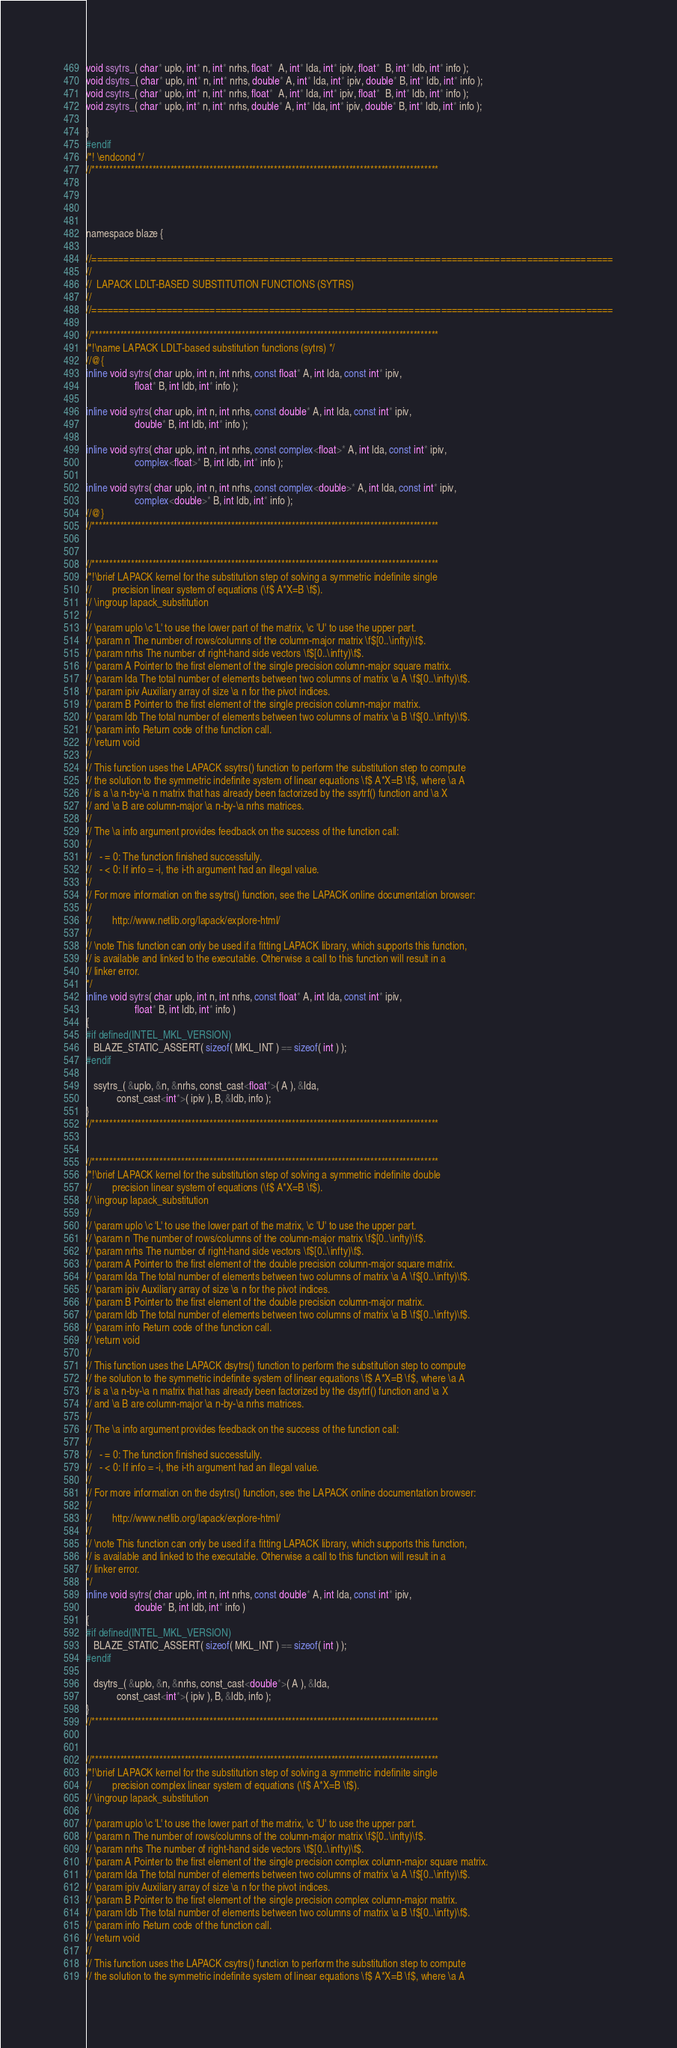Convert code to text. <code><loc_0><loc_0><loc_500><loc_500><_C_>
void ssytrs_( char* uplo, int* n, int* nrhs, float*  A, int* lda, int* ipiv, float*  B, int* ldb, int* info );
void dsytrs_( char* uplo, int* n, int* nrhs, double* A, int* lda, int* ipiv, double* B, int* ldb, int* info );
void csytrs_( char* uplo, int* n, int* nrhs, float*  A, int* lda, int* ipiv, float*  B, int* ldb, int* info );
void zsytrs_( char* uplo, int* n, int* nrhs, double* A, int* lda, int* ipiv, double* B, int* ldb, int* info );

}
#endif
/*! \endcond */
//*************************************************************************************************




namespace blaze {

//=================================================================================================
//
//  LAPACK LDLT-BASED SUBSTITUTION FUNCTIONS (SYTRS)
//
//=================================================================================================

//*************************************************************************************************
/*!\name LAPACK LDLT-based substitution functions (sytrs) */
//@{
inline void sytrs( char uplo, int n, int nrhs, const float* A, int lda, const int* ipiv,
                   float* B, int ldb, int* info );

inline void sytrs( char uplo, int n, int nrhs, const double* A, int lda, const int* ipiv,
                   double* B, int ldb, int* info );

inline void sytrs( char uplo, int n, int nrhs, const complex<float>* A, int lda, const int* ipiv,
                   complex<float>* B, int ldb, int* info );

inline void sytrs( char uplo, int n, int nrhs, const complex<double>* A, int lda, const int* ipiv,
                   complex<double>* B, int ldb, int* info );
//@}
//*************************************************************************************************


//*************************************************************************************************
/*!\brief LAPACK kernel for the substitution step of solving a symmetric indefinite single
//        precision linear system of equations (\f$ A*X=B \f$).
// \ingroup lapack_substitution
//
// \param uplo \c 'L' to use the lower part of the matrix, \c 'U' to use the upper part.
// \param n The number of rows/columns of the column-major matrix \f$[0..\infty)\f$.
// \param nrhs The number of right-hand side vectors \f$[0..\infty)\f$.
// \param A Pointer to the first element of the single precision column-major square matrix.
// \param lda The total number of elements between two columns of matrix \a A \f$[0..\infty)\f$.
// \param ipiv Auxiliary array of size \a n for the pivot indices.
// \param B Pointer to the first element of the single precision column-major matrix.
// \param ldb The total number of elements between two columns of matrix \a B \f$[0..\infty)\f$.
// \param info Return code of the function call.
// \return void
//
// This function uses the LAPACK ssytrs() function to perform the substitution step to compute
// the solution to the symmetric indefinite system of linear equations \f$ A*X=B \f$, where \a A
// is a \a n-by-\a n matrix that has already been factorized by the ssytrf() function and \a X
// and \a B are column-major \a n-by-\a nrhs matrices.
//
// The \a info argument provides feedback on the success of the function call:
//
//   - = 0: The function finished successfully.
//   - < 0: If info = -i, the i-th argument had an illegal value.
//
// For more information on the ssytrs() function, see the LAPACK online documentation browser:
//
//        http://www.netlib.org/lapack/explore-html/
//
// \note This function can only be used if a fitting LAPACK library, which supports this function,
// is available and linked to the executable. Otherwise a call to this function will result in a
// linker error.
*/
inline void sytrs( char uplo, int n, int nrhs, const float* A, int lda, const int* ipiv,
                   float* B, int ldb, int* info )
{
#if defined(INTEL_MKL_VERSION)
   BLAZE_STATIC_ASSERT( sizeof( MKL_INT ) == sizeof( int ) );
#endif

   ssytrs_( &uplo, &n, &nrhs, const_cast<float*>( A ), &lda,
            const_cast<int*>( ipiv ), B, &ldb, info );
}
//*************************************************************************************************


//*************************************************************************************************
/*!\brief LAPACK kernel for the substitution step of solving a symmetric indefinite double
//        precision linear system of equations (\f$ A*X=B \f$).
// \ingroup lapack_substitution
//
// \param uplo \c 'L' to use the lower part of the matrix, \c 'U' to use the upper part.
// \param n The number of rows/columns of the column-major matrix \f$[0..\infty)\f$.
// \param nrhs The number of right-hand side vectors \f$[0..\infty)\f$.
// \param A Pointer to the first element of the double precision column-major square matrix.
// \param lda The total number of elements between two columns of matrix \a A \f$[0..\infty)\f$.
// \param ipiv Auxiliary array of size \a n for the pivot indices.
// \param B Pointer to the first element of the double precision column-major matrix.
// \param ldb The total number of elements between two columns of matrix \a B \f$[0..\infty)\f$.
// \param info Return code of the function call.
// \return void
//
// This function uses the LAPACK dsytrs() function to perform the substitution step to compute
// the solution to the symmetric indefinite system of linear equations \f$ A*X=B \f$, where \a A
// is a \a n-by-\a n matrix that has already been factorized by the dsytrf() function and \a X
// and \a B are column-major \a n-by-\a nrhs matrices.
//
// The \a info argument provides feedback on the success of the function call:
//
//   - = 0: The function finished successfully.
//   - < 0: If info = -i, the i-th argument had an illegal value.
//
// For more information on the dsytrs() function, see the LAPACK online documentation browser:
//
//        http://www.netlib.org/lapack/explore-html/
//
// \note This function can only be used if a fitting LAPACK library, which supports this function,
// is available and linked to the executable. Otherwise a call to this function will result in a
// linker error.
*/
inline void sytrs( char uplo, int n, int nrhs, const double* A, int lda, const int* ipiv,
                   double* B, int ldb, int* info )
{
#if defined(INTEL_MKL_VERSION)
   BLAZE_STATIC_ASSERT( sizeof( MKL_INT ) == sizeof( int ) );
#endif

   dsytrs_( &uplo, &n, &nrhs, const_cast<double*>( A ), &lda,
            const_cast<int*>( ipiv ), B, &ldb, info );
}
//*************************************************************************************************


//*************************************************************************************************
/*!\brief LAPACK kernel for the substitution step of solving a symmetric indefinite single
//        precision complex linear system of equations (\f$ A*X=B \f$).
// \ingroup lapack_substitution
//
// \param uplo \c 'L' to use the lower part of the matrix, \c 'U' to use the upper part.
// \param n The number of rows/columns of the column-major matrix \f$[0..\infty)\f$.
// \param nrhs The number of right-hand side vectors \f$[0..\infty)\f$.
// \param A Pointer to the first element of the single precision complex column-major square matrix.
// \param lda The total number of elements between two columns of matrix \a A \f$[0..\infty)\f$.
// \param ipiv Auxiliary array of size \a n for the pivot indices.
// \param B Pointer to the first element of the single precision complex column-major matrix.
// \param ldb The total number of elements between two columns of matrix \a B \f$[0..\infty)\f$.
// \param info Return code of the function call.
// \return void
//
// This function uses the LAPACK csytrs() function to perform the substitution step to compute
// the solution to the symmetric indefinite system of linear equations \f$ A*X=B \f$, where \a A</code> 